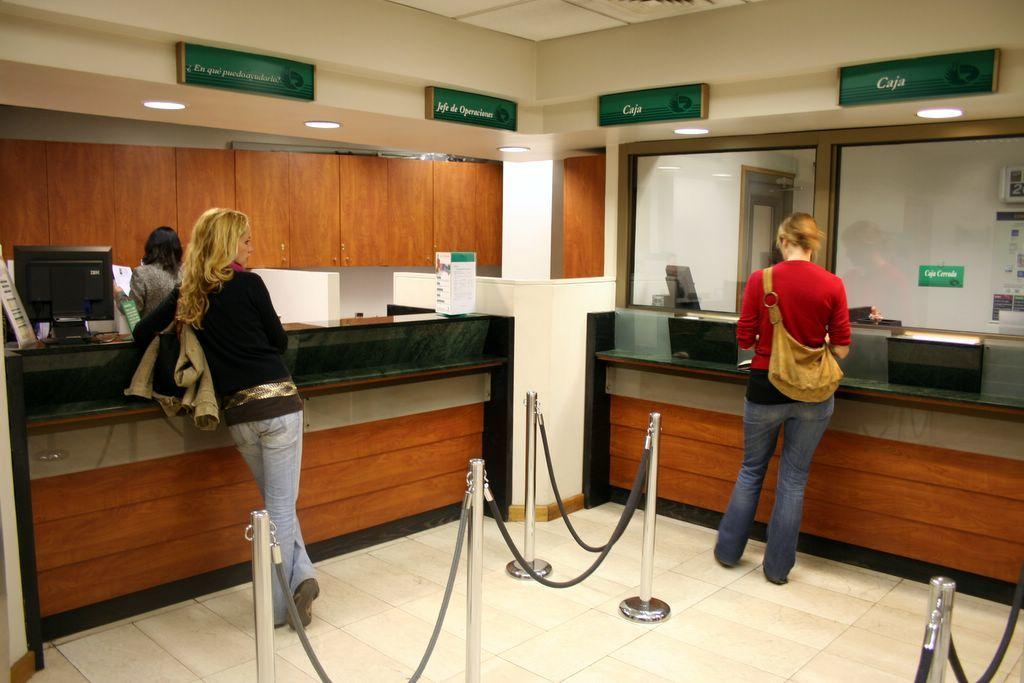Who or what can be seen in the image? There are people in the image. What is on the floor in the image? There is a fence on the floor in the image. What type of electronic devices are present in the image? Monitors are present in the image. What are the boards used for in the image? The boards are visible in the image, but their purpose is not specified. What type of lighting is present in the image? Lights are present in the image. Can you describe any other objects in the image? There are some unspecified objects in the image. What can be seen in the background of the image? There is a wooden wall in the background of the image. What type of trousers is the egg wearing in the image? There is no egg or trousers present in the image. What is the engine used for in the image? There is no engine present in the image. 